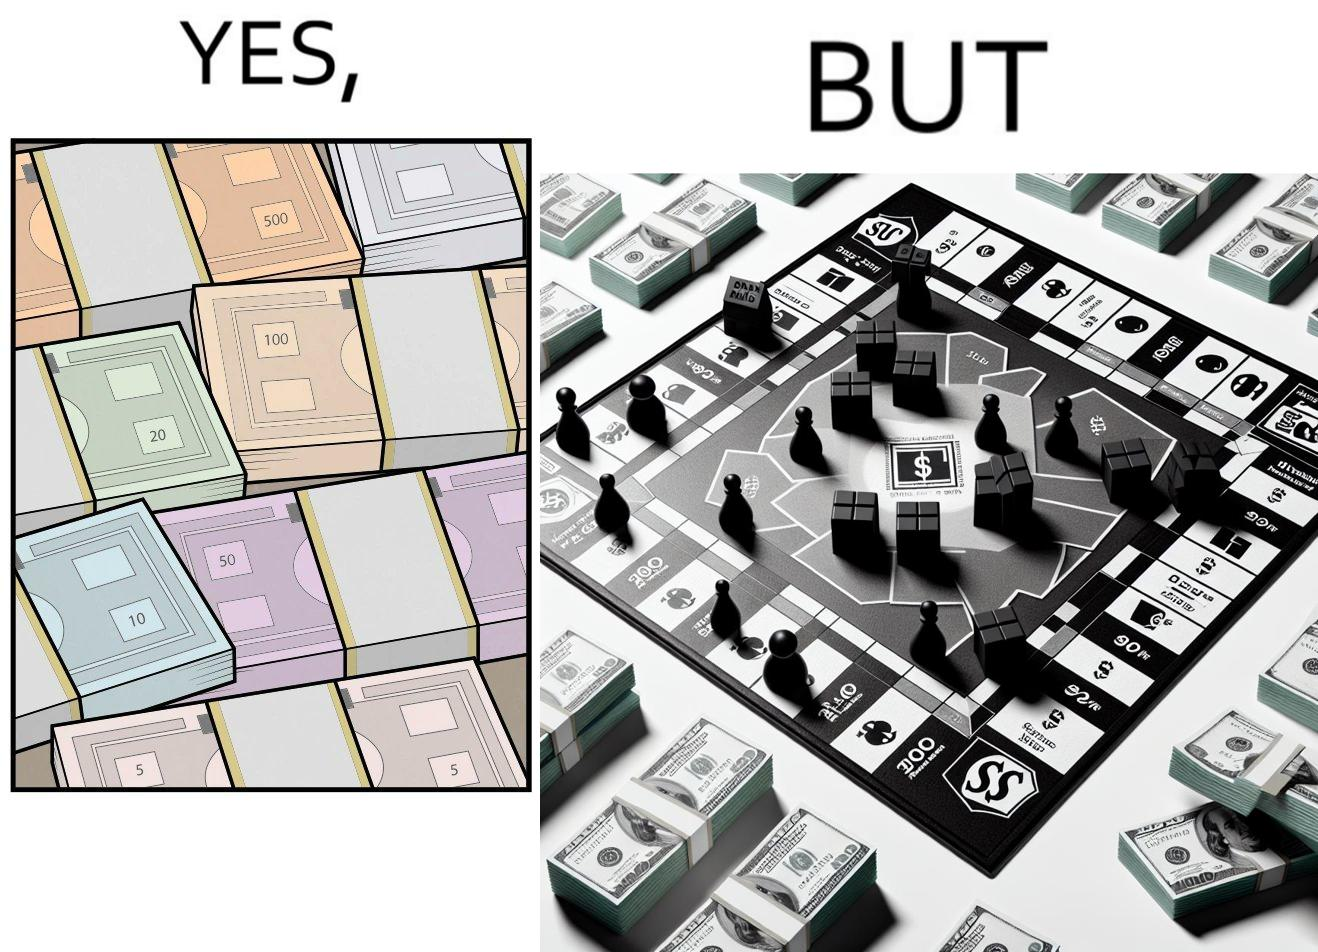Why is this image considered satirical? The image is ironic, because there are many different color currency notes' bundles but they are just as a currency in the game of monopoly and they have no real value 